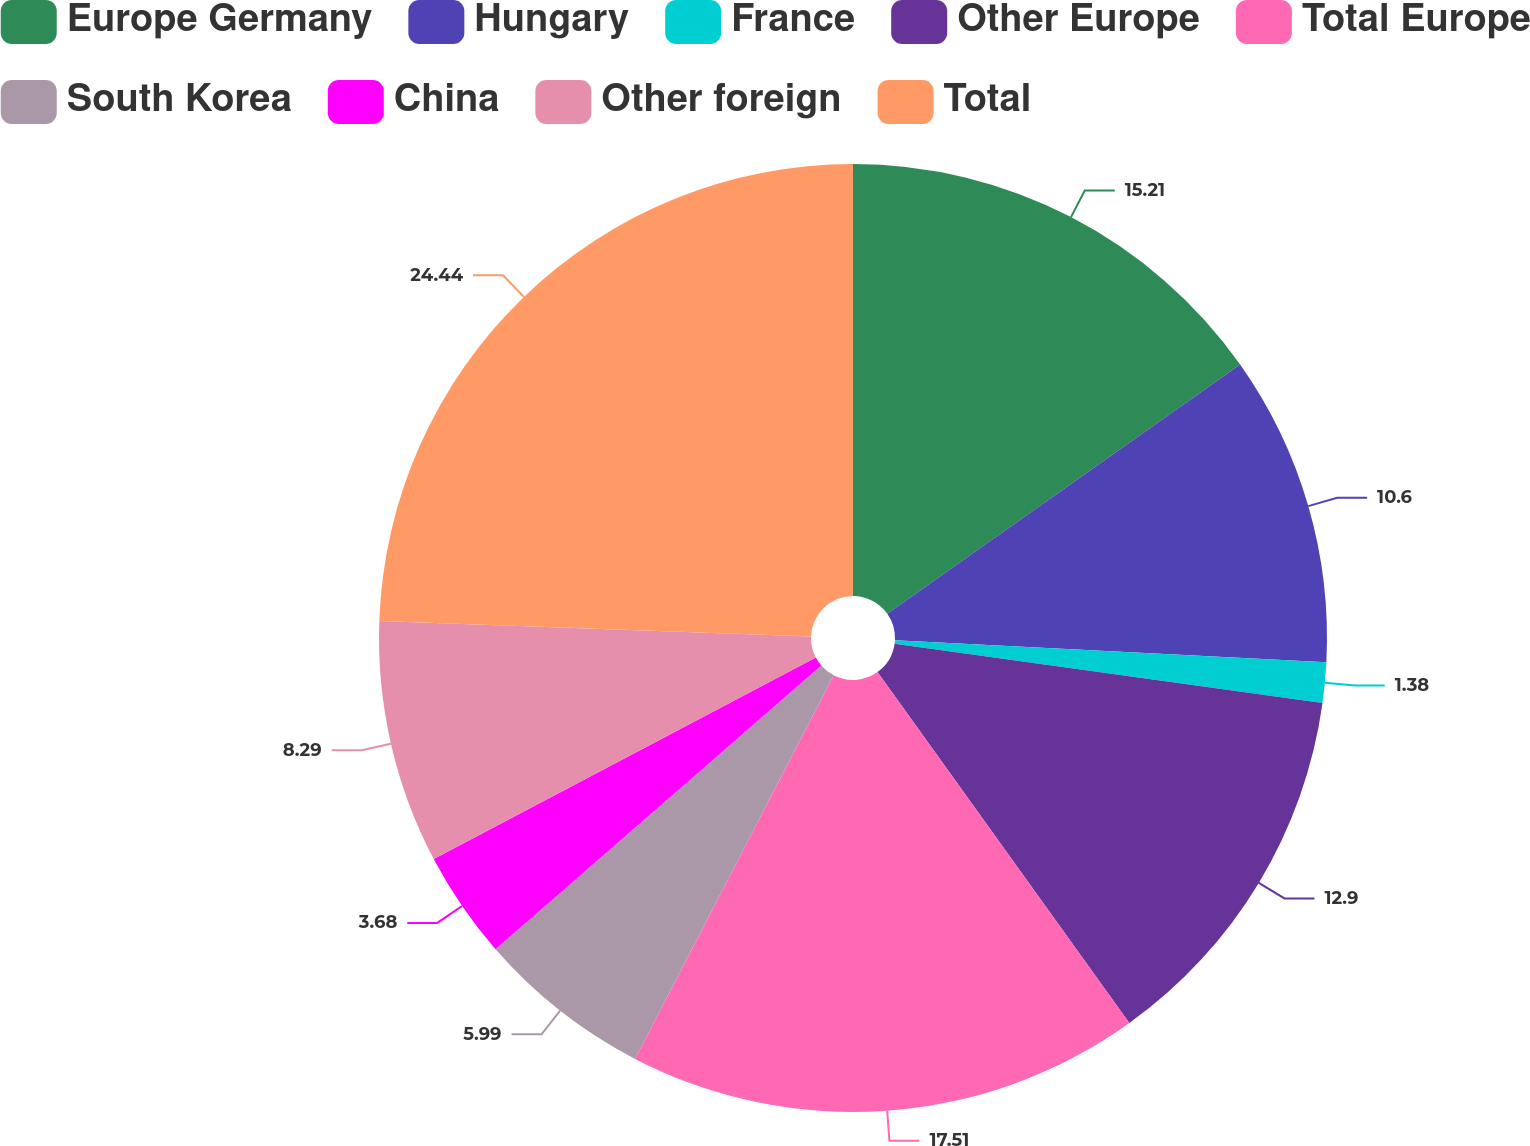<chart> <loc_0><loc_0><loc_500><loc_500><pie_chart><fcel>Europe Germany<fcel>Hungary<fcel>France<fcel>Other Europe<fcel>Total Europe<fcel>South Korea<fcel>China<fcel>Other foreign<fcel>Total<nl><fcel>15.21%<fcel>10.6%<fcel>1.38%<fcel>12.9%<fcel>17.51%<fcel>5.99%<fcel>3.68%<fcel>8.29%<fcel>24.43%<nl></chart> 